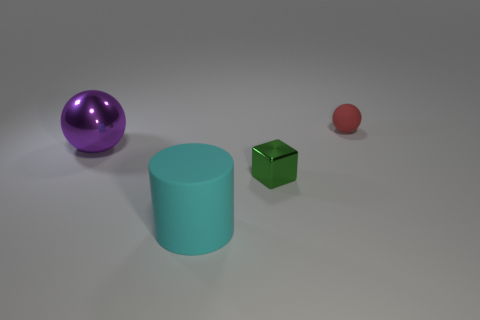Add 1 small matte things. How many objects exist? 5 Subtract all blocks. How many objects are left? 3 Add 1 cyan objects. How many cyan objects exist? 2 Subtract 0 green balls. How many objects are left? 4 Subtract all big metallic spheres. Subtract all small metal blocks. How many objects are left? 2 Add 3 cyan matte objects. How many cyan matte objects are left? 4 